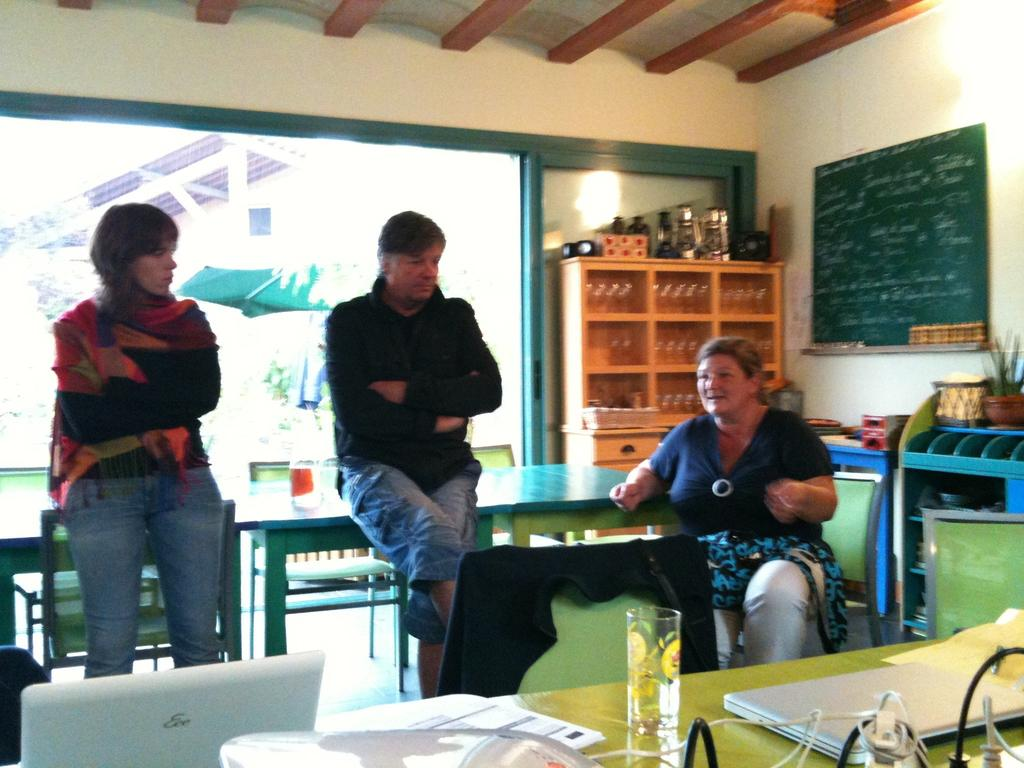What are the people in the image doing? The group of people is sitting on chairs. What is on the table in the image? There is a laptop and other objects on the table. Can you describe the laptop's location in the image? The laptop is present on the table. What else can be seen in the image besides the people and the table? There is a pot and a wall in the image. What type of horn can be heard in the image? There is no horn present or audible in the image. What activity is the daughter participating in with the group of people? There is no mention of a daughter in the image, and the group of people is not participating in any specific activity. 